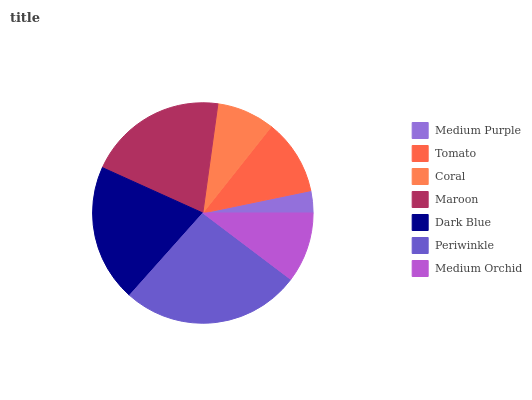Is Medium Purple the minimum?
Answer yes or no. Yes. Is Periwinkle the maximum?
Answer yes or no. Yes. Is Tomato the minimum?
Answer yes or no. No. Is Tomato the maximum?
Answer yes or no. No. Is Tomato greater than Medium Purple?
Answer yes or no. Yes. Is Medium Purple less than Tomato?
Answer yes or no. Yes. Is Medium Purple greater than Tomato?
Answer yes or no. No. Is Tomato less than Medium Purple?
Answer yes or no. No. Is Tomato the high median?
Answer yes or no. Yes. Is Tomato the low median?
Answer yes or no. Yes. Is Maroon the high median?
Answer yes or no. No. Is Dark Blue the low median?
Answer yes or no. No. 